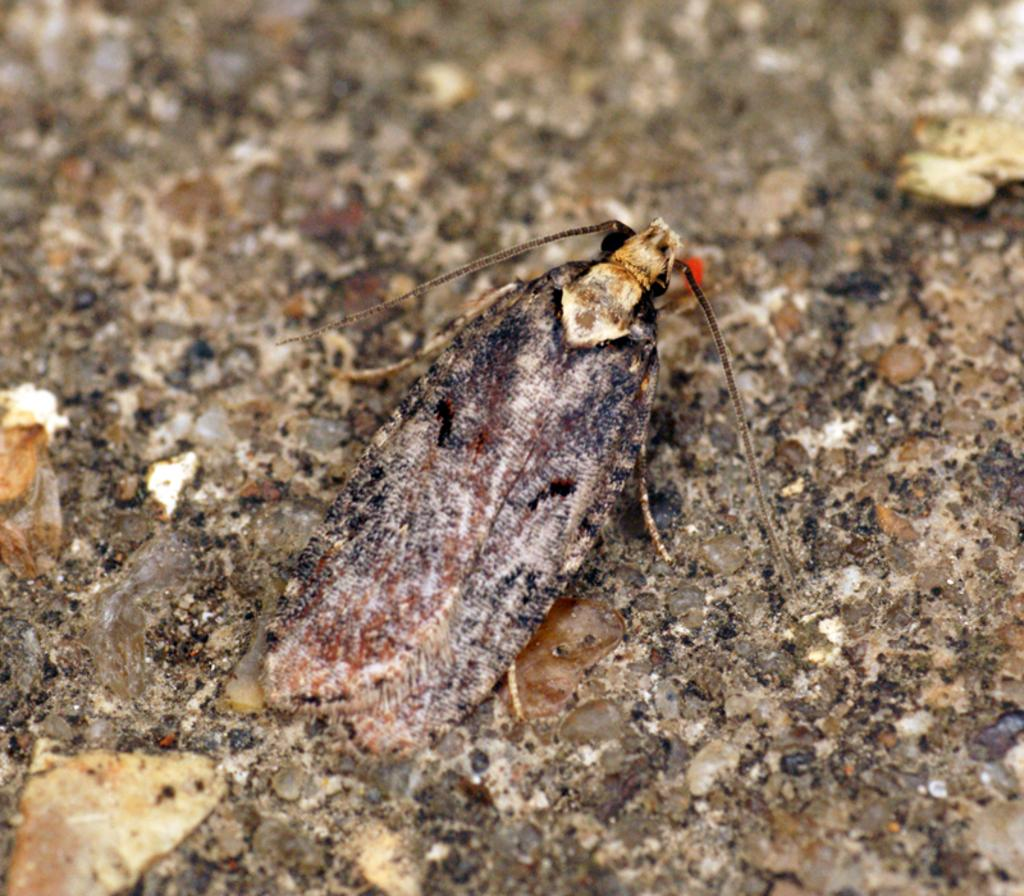What type of creature can be seen in the image? There is an insect in the image. What is the color of the insect? The insect is brown in color. How many cattle are grazing in the background of the image? There is no background or cattle present in the image; it only features an insect. 